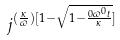<formula> <loc_0><loc_0><loc_500><loc_500>j ^ { ( \frac { \kappa } { \varpi } ) [ 1 - \sqrt { 1 - \frac { 0 \varpi ^ { 0 } t } { \kappa } } ] }</formula> 